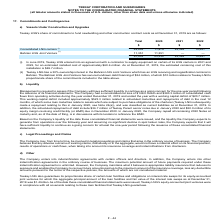According to Teekay Corporation's financial document, What agreement did Teekay LNG entered in June 2019? with a contractor to supply equipment on certain of its LNG carriers in 2021 and 2022. The document states: "n June 2019, Teekay LNG entered into an agreement with a contractor to supply equipment on certain of its LNG carriers in 2021 and 2022, for an estima..." Also, What was the estimated installed cost of Teenkay LNG's agreement with a contractor? approximately $60.6 million. The document states: "2021 and 2022, for an estimated installed cost of approximately $60.6 million. As at December 31, 2019, the estimated remaining cost of this installat..." Also, What is the remaining cost of installation as at December 31, 2019? According to the financial document, $49.7 million. The relevant text states: "e estimated remaining cost of this installation is $49.7 million...." Also, can you calculate: What is the change in Consolidated LNG carriers from 2020 to 2021? Based on the calculation: 22,382-11,979, the result is 10403 (in thousands). This is based on the information: "Consolidated LNG carriers (i) 49,652 11,979 22,382 15,291 Consolidated LNG carriers (i) 49,652 11,979 22,382 15,291..." The key data points involved are: 11,979, 22,382. Also, can you calculate: What is the change in Consolidated LNG carriers from 2021 to 2022? Based on the calculation: 15,291-22,382, the result is -7091 (in thousands). This is based on the information: "onsolidated LNG carriers (i) 49,652 11,979 22,382 15,291 Consolidated LNG carriers (i) 49,652 11,979 22,382 15,291..." The key data points involved are: 15,291, 22,382. Also, can you calculate: What is the average Consolidated LNG carriers, for the year 2020 to 2021? To answer this question, I need to perform calculations using the financial data. The calculation is: (22,382+11,979) / 2, which equals 17180.5 (in thousands). This is based on the information: "Consolidated LNG carriers (i) 49,652 11,979 22,382 15,291 Consolidated LNG carriers (i) 49,652 11,979 22,382 15,291..." The key data points involved are: 11,979, 22,382. 